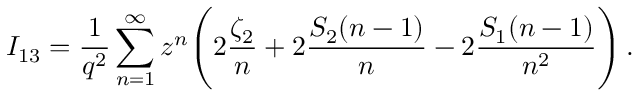<formula> <loc_0><loc_0><loc_500><loc_500>I _ { 1 3 } = \frac { 1 } { q ^ { 2 } } \sum _ { n = 1 } ^ { \infty } z ^ { n } \left ( 2 \frac { \zeta _ { 2 } } { n } + 2 \frac { S _ { 2 } ( n - 1 ) } { n } - 2 \frac { S _ { 1 } ( n - 1 ) } { n ^ { 2 } } \right ) \, .</formula> 